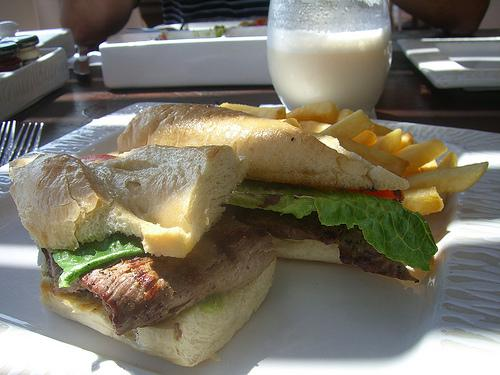Question: where is the plate?
Choices:
A. In the waiter's hand.
B. On the counter.
C. In the sink.
D. Under the sandwich.
Answer with the letter. Answer: D Question: what color is the plate?
Choices:
A. Green.
B. Gray.
C. White.
D. Blue.
Answer with the letter. Answer: C Question: how many forks can you see?
Choices:
A. Two.
B. Twelve.
C. Three.
D. Five.
Answer with the letter. Answer: A Question: how many animals are in the picture?
Choices:
A. Twelve.
B. None.
C. Three.
D. Five.
Answer with the letter. Answer: B Question: what can you see on the sandwich?
Choices:
A. Tomatoes and avocado.
B. Ham and cheese.
C. Lettuce and meat.
D. Tuna fish and lettuce.
Answer with the letter. Answer: C 